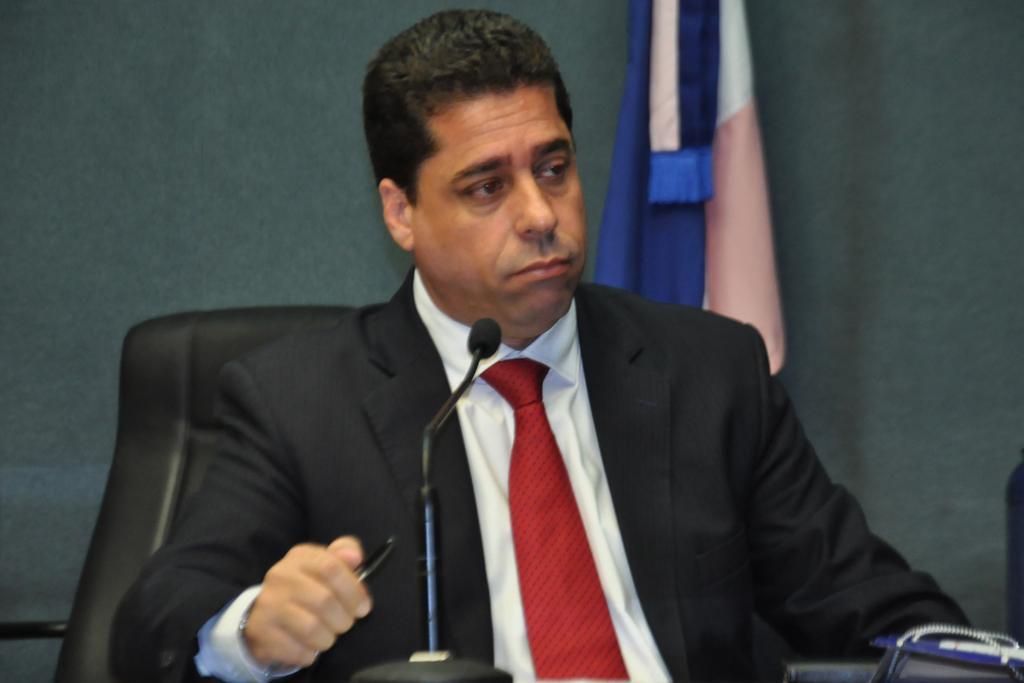How would you summarize this image in a sentence or two? In this image, we can see a person wearing clothes and sitting on the chair in front of the mic. This person is holding a pen with his hand. There is a flag in front of the wall. 